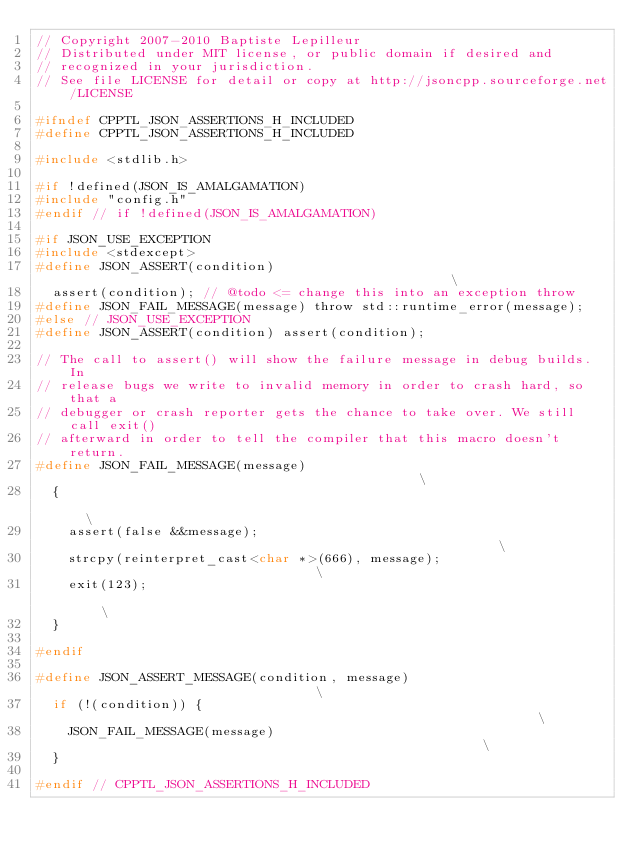Convert code to text. <code><loc_0><loc_0><loc_500><loc_500><_C_>// Copyright 2007-2010 Baptiste Lepilleur
// Distributed under MIT license, or public domain if desired and
// recognized in your jurisdiction.
// See file LICENSE for detail or copy at http://jsoncpp.sourceforge.net/LICENSE

#ifndef CPPTL_JSON_ASSERTIONS_H_INCLUDED
#define CPPTL_JSON_ASSERTIONS_H_INCLUDED

#include <stdlib.h>

#if !defined(JSON_IS_AMALGAMATION)
#include "config.h"
#endif // if !defined(JSON_IS_AMALGAMATION)

#if JSON_USE_EXCEPTION
#include <stdexcept>
#define JSON_ASSERT(condition)                                                 \
  assert(condition); // @todo <= change this into an exception throw
#define JSON_FAIL_MESSAGE(message) throw std::runtime_error(message);
#else // JSON_USE_EXCEPTION
#define JSON_ASSERT(condition) assert(condition);

// The call to assert() will show the failure message in debug builds. In
// release bugs we write to invalid memory in order to crash hard, so that a
// debugger or crash reporter gets the chance to take over. We still call exit()
// afterward in order to tell the compiler that this macro doesn't return.
#define JSON_FAIL_MESSAGE(message)                                             \
  {                                                                            \
    assert(false &&message);                                                   \
    strcpy(reinterpret_cast<char *>(666), message);                            \
    exit(123);                                                                 \
  }

#endif

#define JSON_ASSERT_MESSAGE(condition, message)                                \
  if (!(condition)) {                                                          \
    JSON_FAIL_MESSAGE(message)                                                 \
  }

#endif // CPPTL_JSON_ASSERTIONS_H_INCLUDED
</code> 